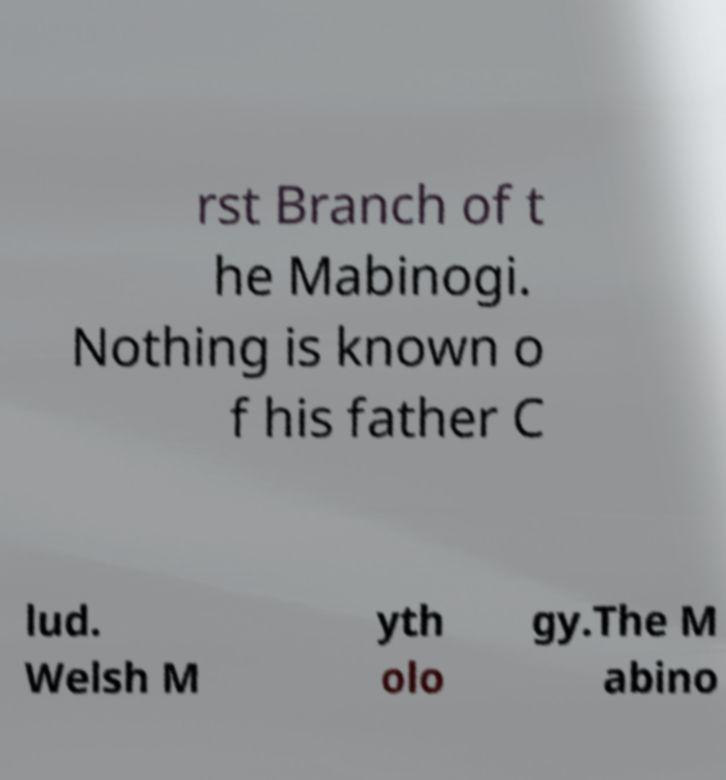Could you assist in decoding the text presented in this image and type it out clearly? rst Branch of t he Mabinogi. Nothing is known o f his father C lud. Welsh M yth olo gy.The M abino 